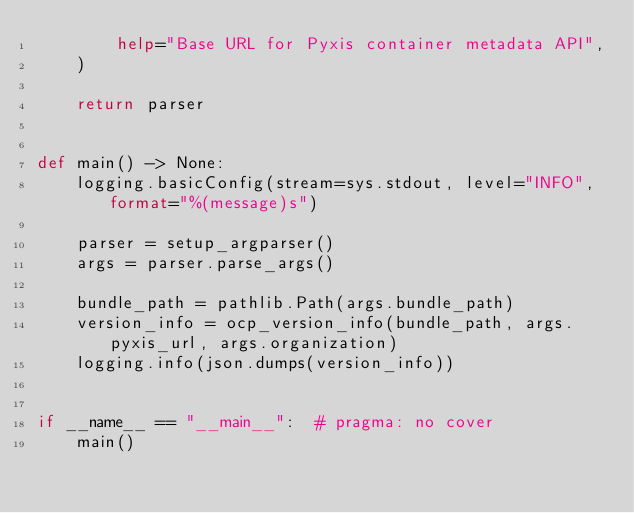Convert code to text. <code><loc_0><loc_0><loc_500><loc_500><_Python_>        help="Base URL for Pyxis container metadata API",
    )

    return parser


def main() -> None:
    logging.basicConfig(stream=sys.stdout, level="INFO", format="%(message)s")

    parser = setup_argparser()
    args = parser.parse_args()

    bundle_path = pathlib.Path(args.bundle_path)
    version_info = ocp_version_info(bundle_path, args.pyxis_url, args.organization)
    logging.info(json.dumps(version_info))


if __name__ == "__main__":  # pragma: no cover
    main()
</code> 